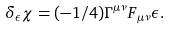Convert formula to latex. <formula><loc_0><loc_0><loc_500><loc_500>\delta _ { \epsilon } \chi = ( - 1 / 4 ) \Gamma ^ { \mu \nu } F _ { \mu \nu } \epsilon .</formula> 